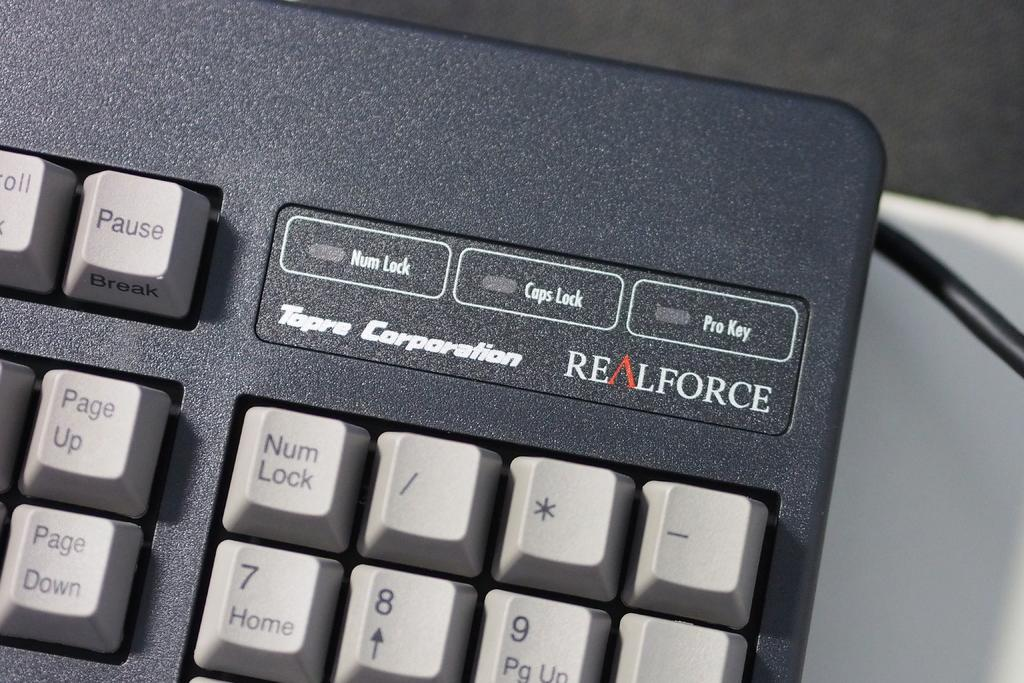What is the main object in the image? There is a keyboard in the image. Can you describe any additional features of the keyboard? Yes, there is text written on the keyboard. What type of road can be seen in the image? There is no road present in the image; it features a keyboard with text on it. Can you describe the girl sitting next to the keyboard in the image? There is no girl present in the image; it only features a keyboard with text on it. 